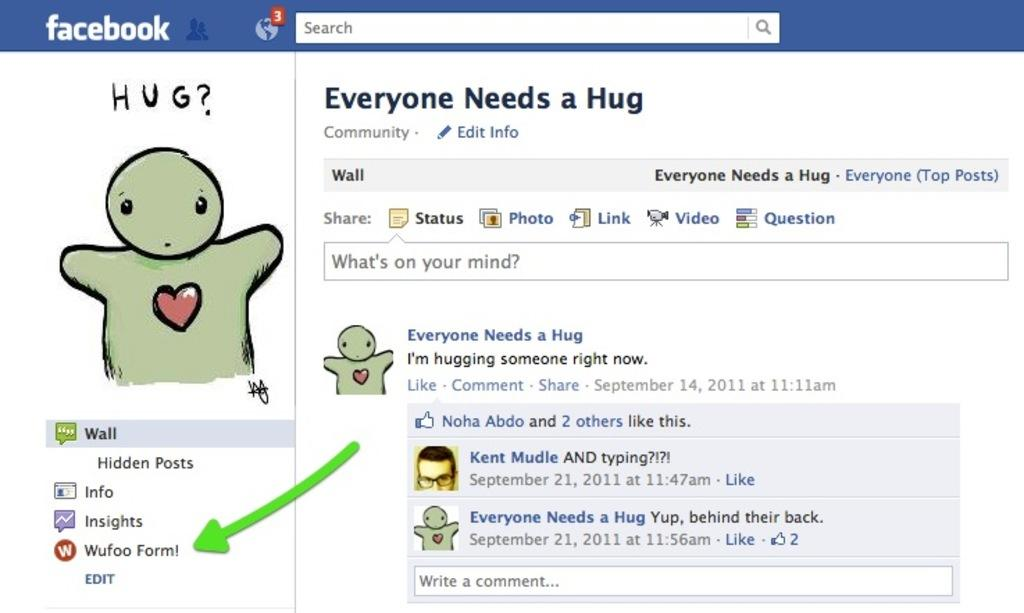What social media platform is featured in the image? There is a Facebook page in the image. Can you describe the person in the image? The person is wearing glasses. What symbol is present in the image? There is a heart in the image. What grade did the person receive on their latest test, as shown in the image? There is no information about a test or grade in the image. What type of humor is being displayed in the image? There is no humor or joke present in the image. 